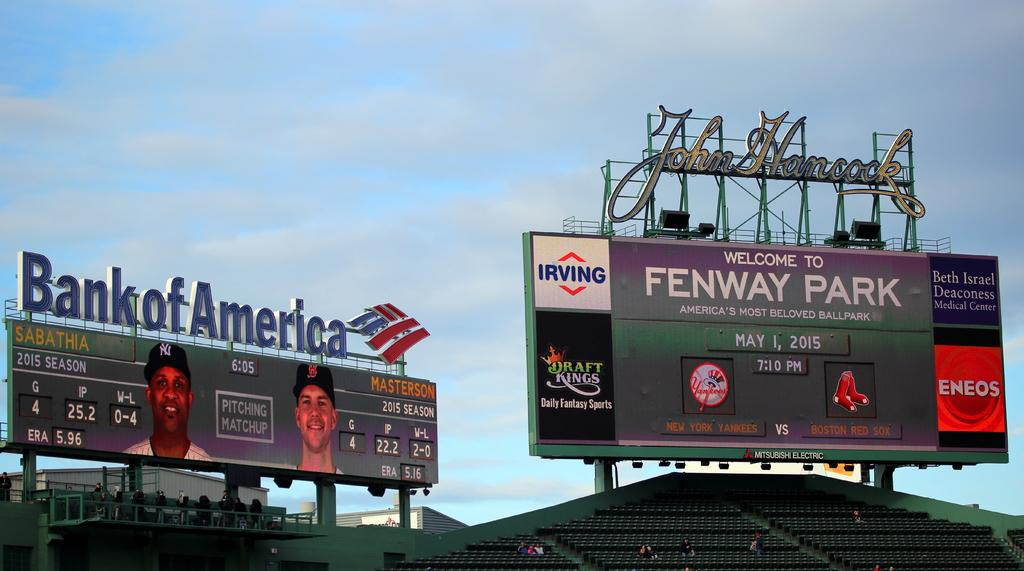<image>
Offer a succinct explanation of the picture presented. A sign at the baseball stadium reads Welcome to Fenway Park. 